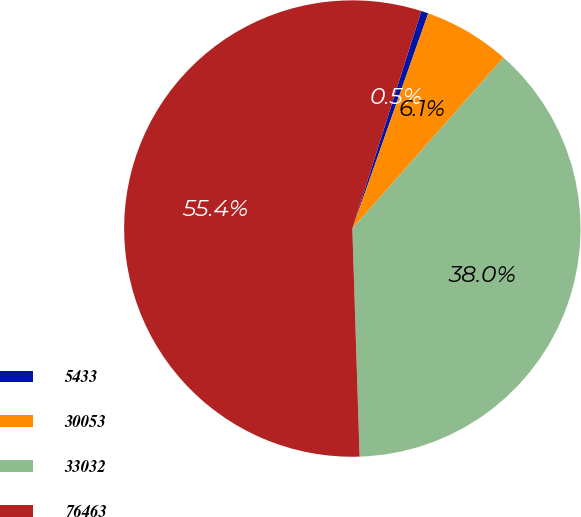Convert chart to OTSL. <chart><loc_0><loc_0><loc_500><loc_500><pie_chart><fcel>5433<fcel>30053<fcel>33032<fcel>76463<nl><fcel>0.51%<fcel>6.13%<fcel>37.97%<fcel>55.39%<nl></chart> 